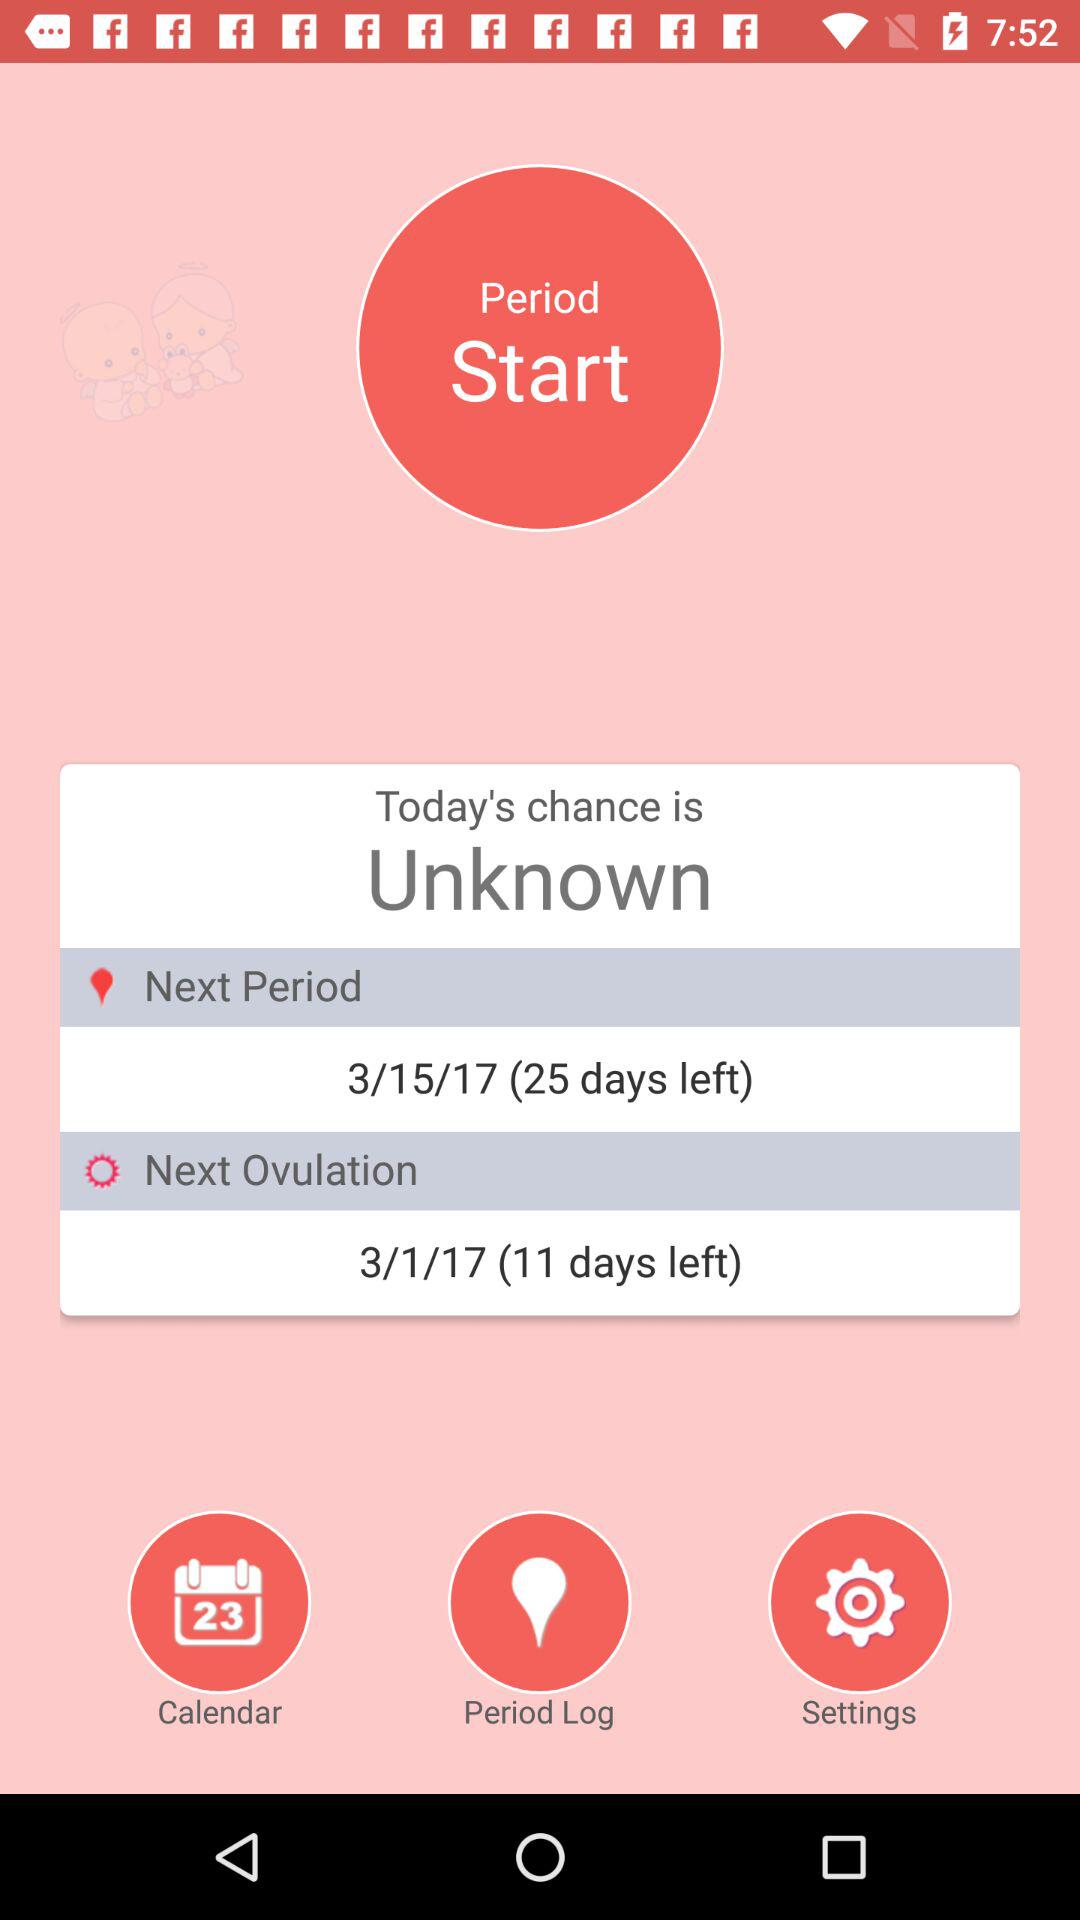How many days are left until the next period?
Answer the question using a single word or phrase. 25 days 